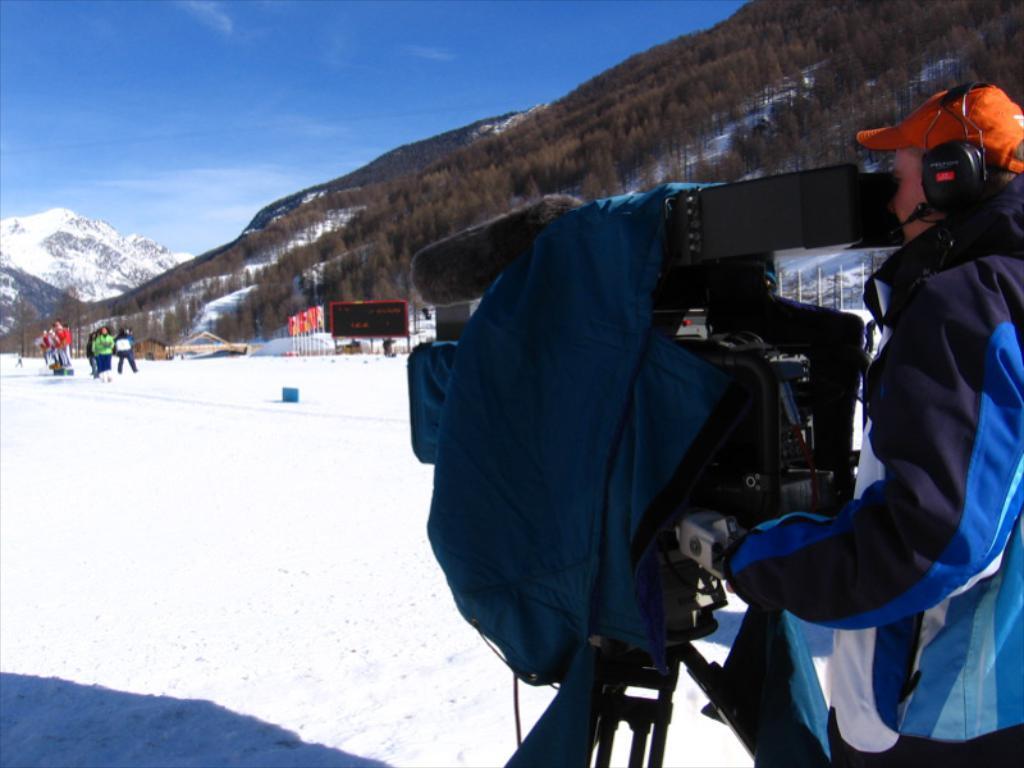How would you summarize this image in a sentence or two? In this image, we can see a person wearing headset, cap and a coat and there is a camera stand and a cloth. In the background, there are flags, boards, some people and there are poles, trees and hills. At the top, there is sky and at the bottom, there is snow. 